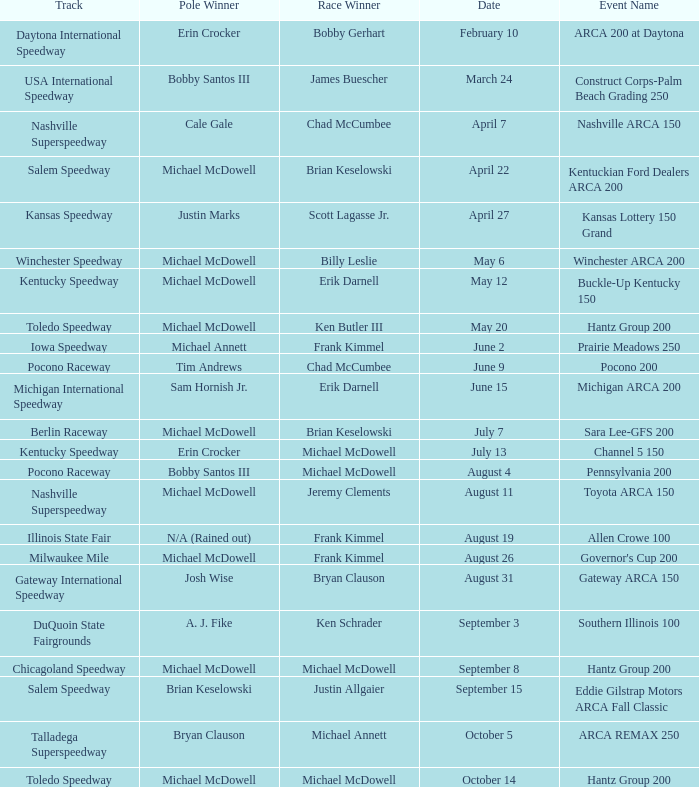Tell me the track for scott lagasse jr. Kansas Speedway. 